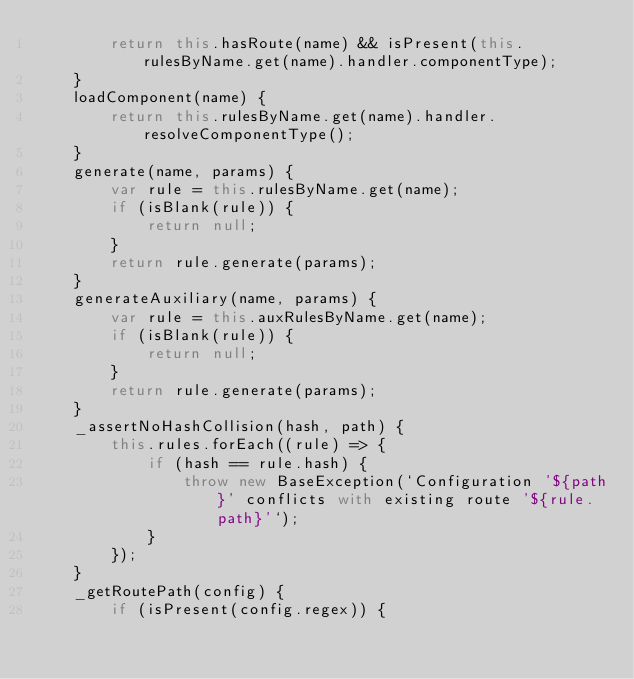Convert code to text. <code><loc_0><loc_0><loc_500><loc_500><_JavaScript_>        return this.hasRoute(name) && isPresent(this.rulesByName.get(name).handler.componentType);
    }
    loadComponent(name) {
        return this.rulesByName.get(name).handler.resolveComponentType();
    }
    generate(name, params) {
        var rule = this.rulesByName.get(name);
        if (isBlank(rule)) {
            return null;
        }
        return rule.generate(params);
    }
    generateAuxiliary(name, params) {
        var rule = this.auxRulesByName.get(name);
        if (isBlank(rule)) {
            return null;
        }
        return rule.generate(params);
    }
    _assertNoHashCollision(hash, path) {
        this.rules.forEach((rule) => {
            if (hash == rule.hash) {
                throw new BaseException(`Configuration '${path}' conflicts with existing route '${rule.path}'`);
            }
        });
    }
    _getRoutePath(config) {
        if (isPresent(config.regex)) {</code> 